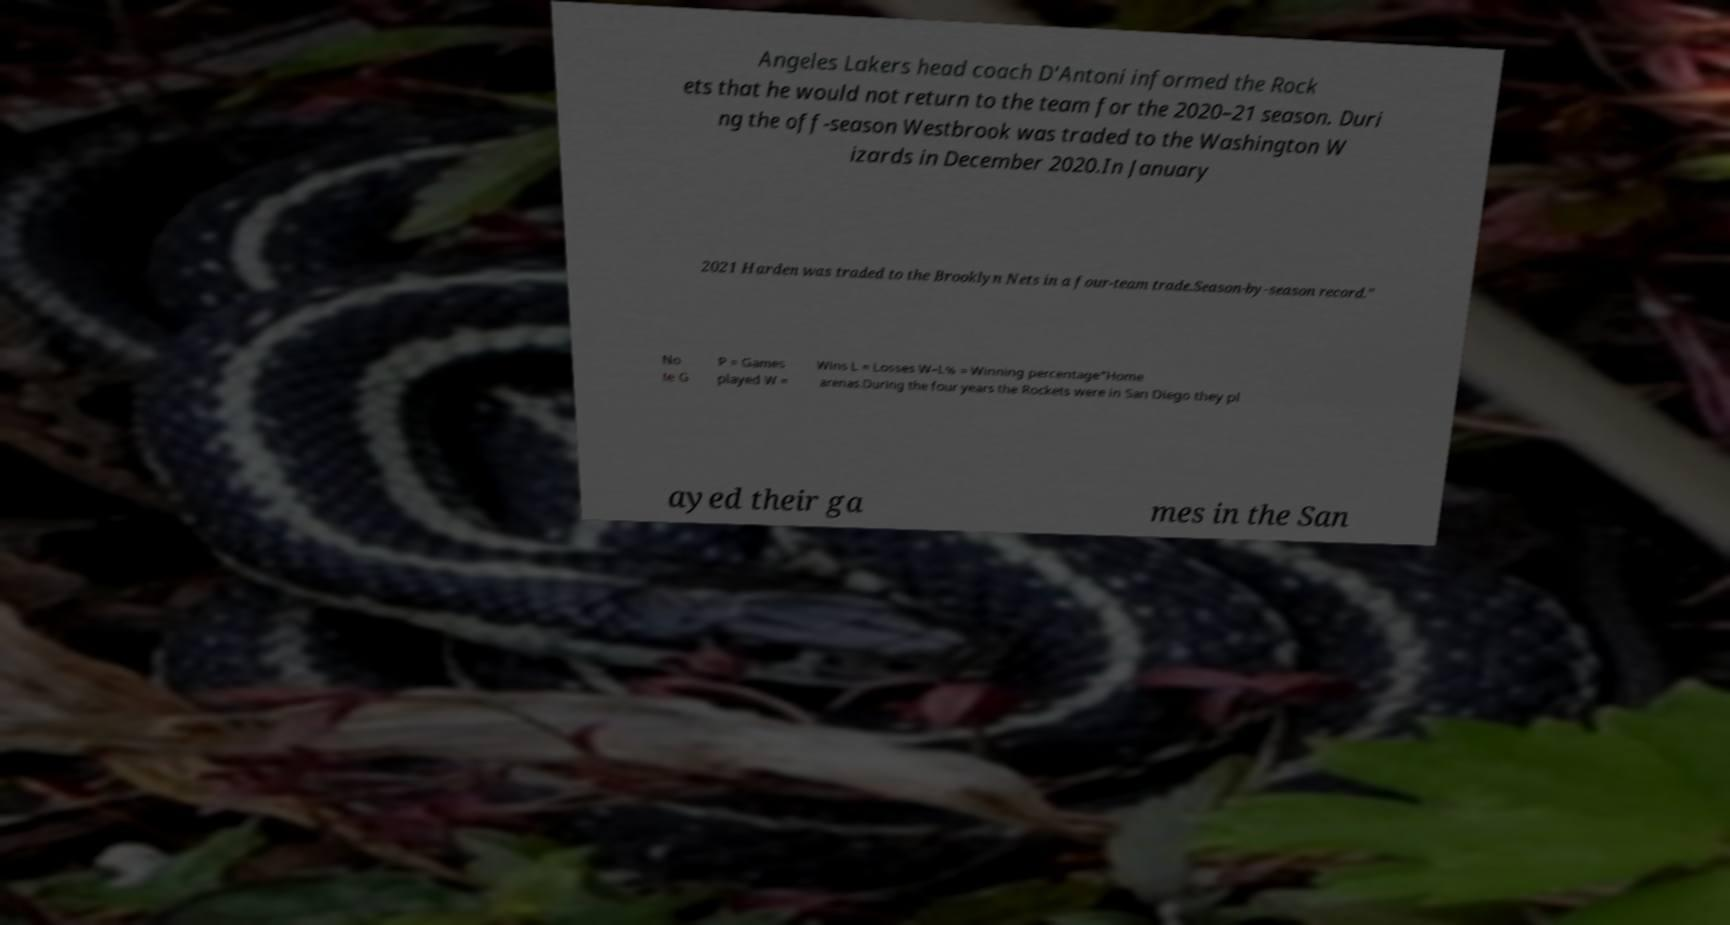What messages or text are displayed in this image? I need them in a readable, typed format. Angeles Lakers head coach D'Antoni informed the Rock ets that he would not return to the team for the 2020–21 season. Duri ng the off-season Westbrook was traded to the Washington W izards in December 2020.In January 2021 Harden was traded to the Brooklyn Nets in a four-team trade.Season-by-season record." No te G P = Games played W = Wins L = Losses W–L% = Winning percentage"Home arenas.During the four years the Rockets were in San Diego they pl ayed their ga mes in the San 